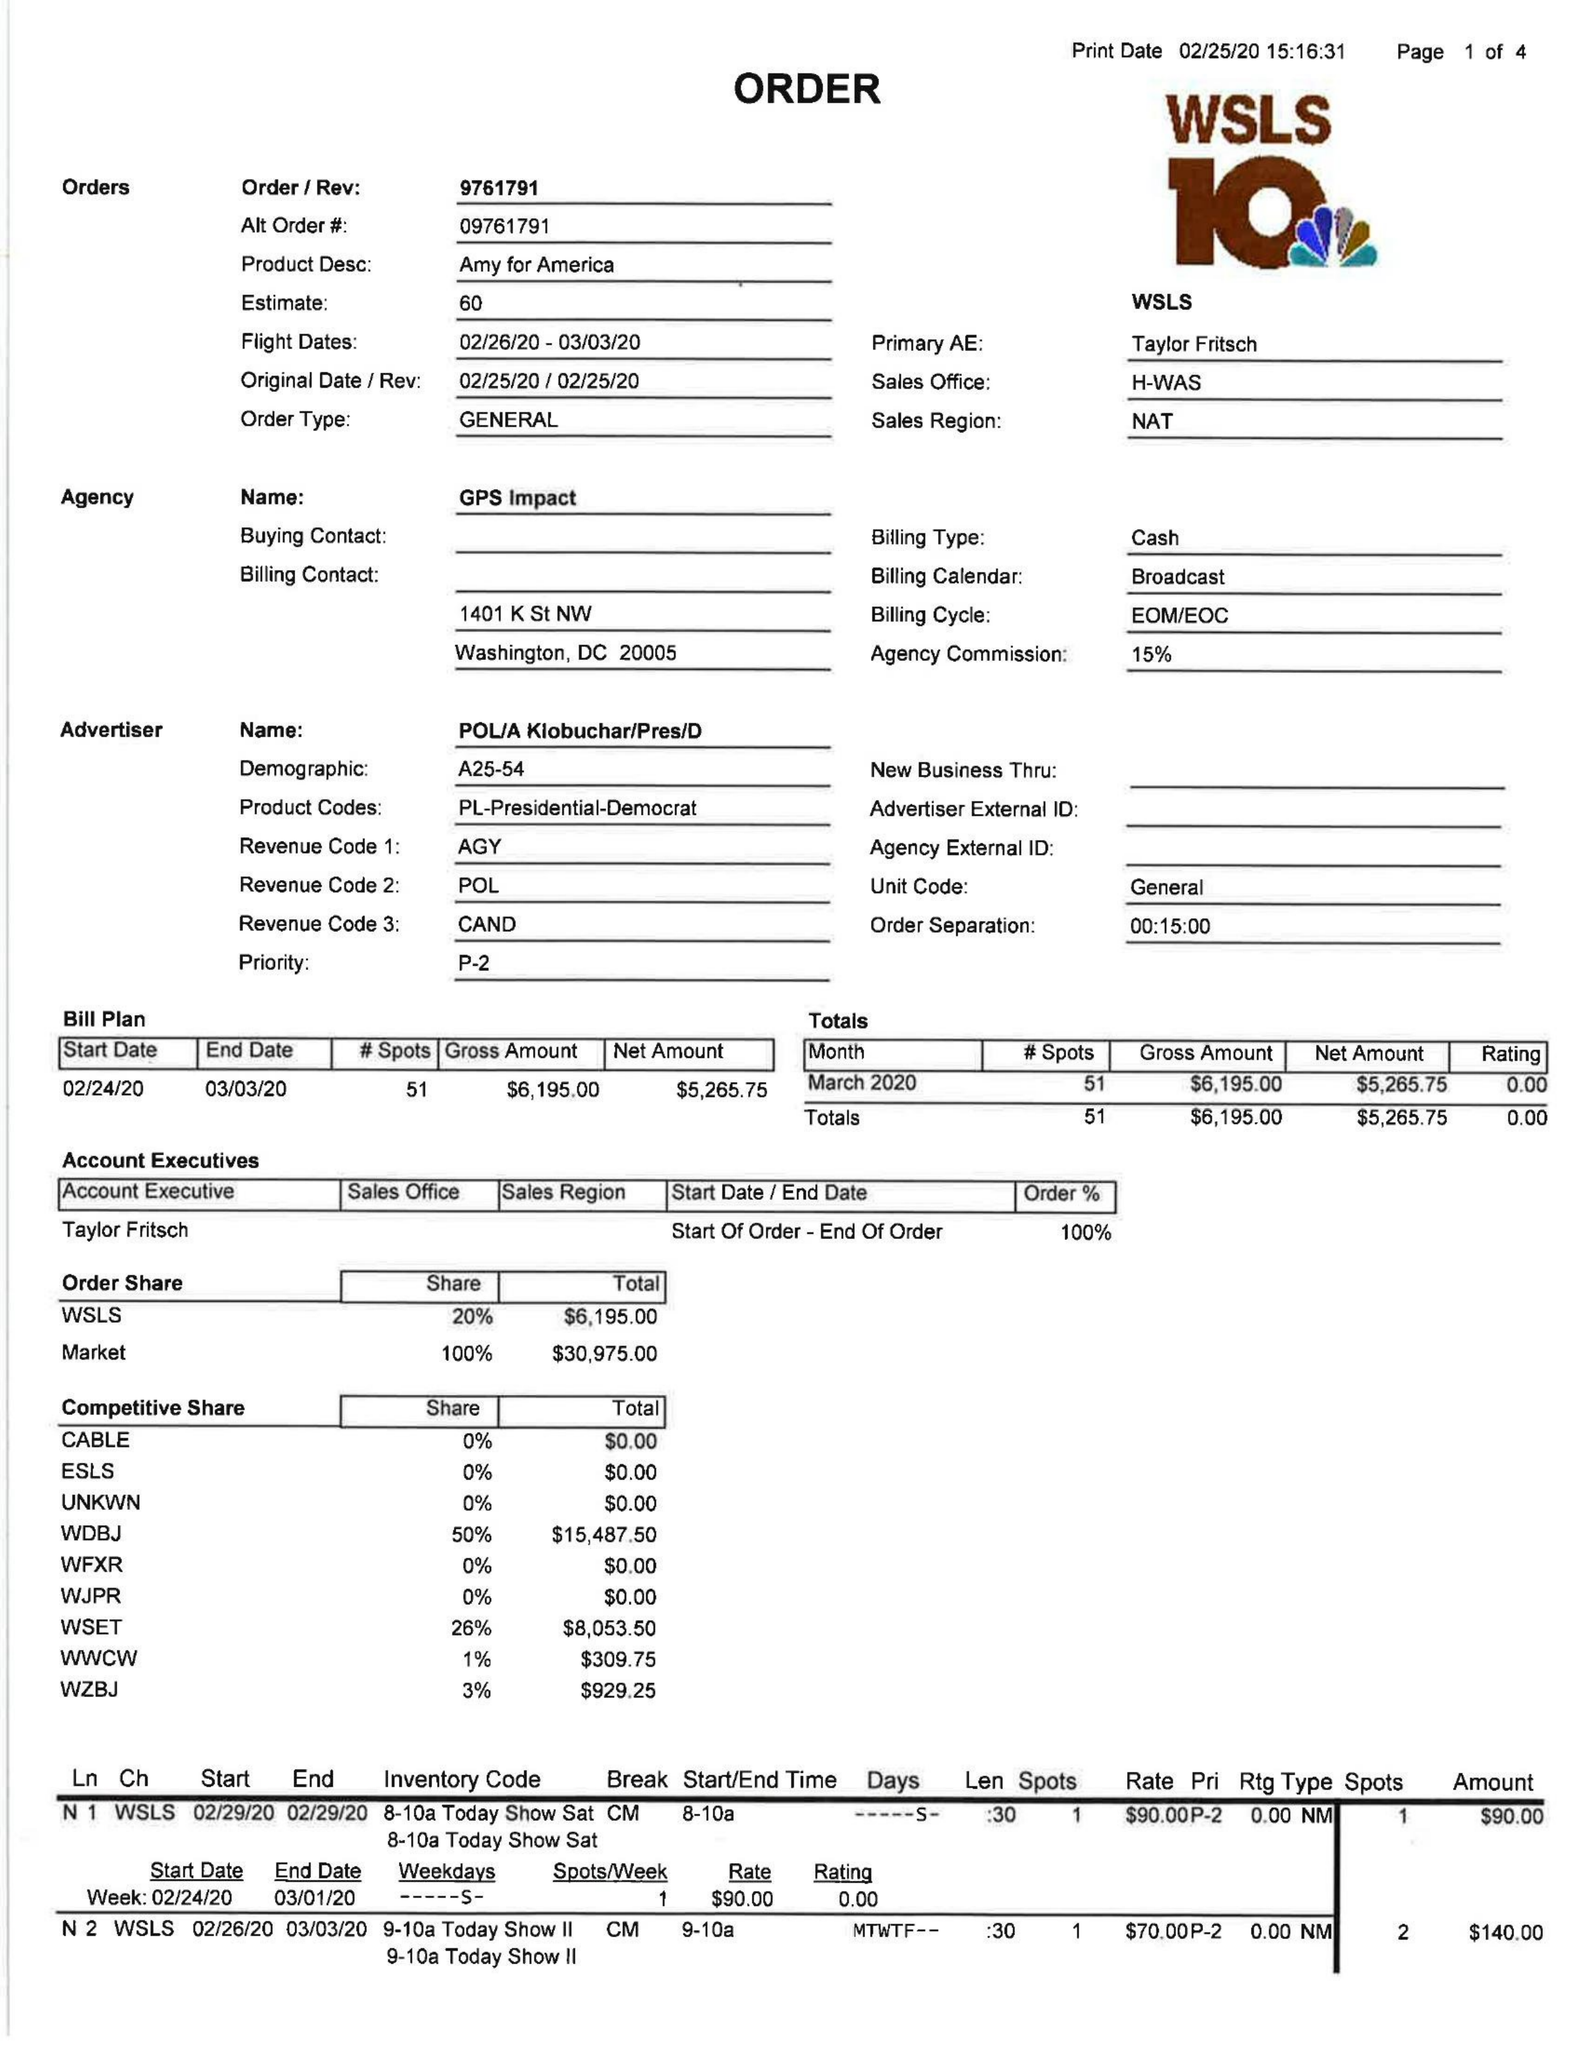What is the value for the flight_from?
Answer the question using a single word or phrase. 02/26/20 